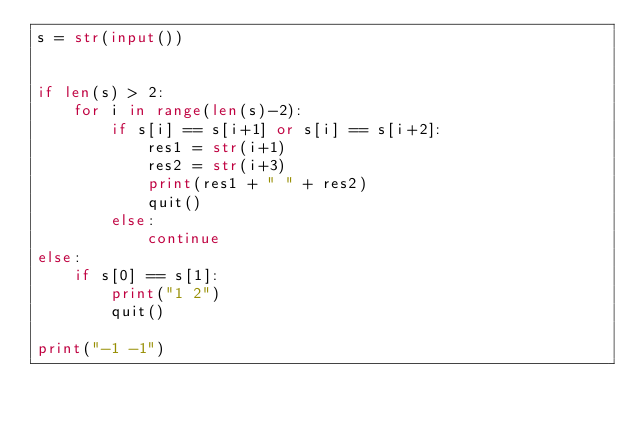Convert code to text. <code><loc_0><loc_0><loc_500><loc_500><_Python_>s = str(input())


if len(s) > 2:
    for i in range(len(s)-2):
        if s[i] == s[i+1] or s[i] == s[i+2]:
            res1 = str(i+1)
            res2 = str(i+3)
            print(res1 + " " + res2)
            quit()
        else:
            continue
else:
    if s[0] == s[1]:
        print("1 2")
        quit()

print("-1 -1")</code> 